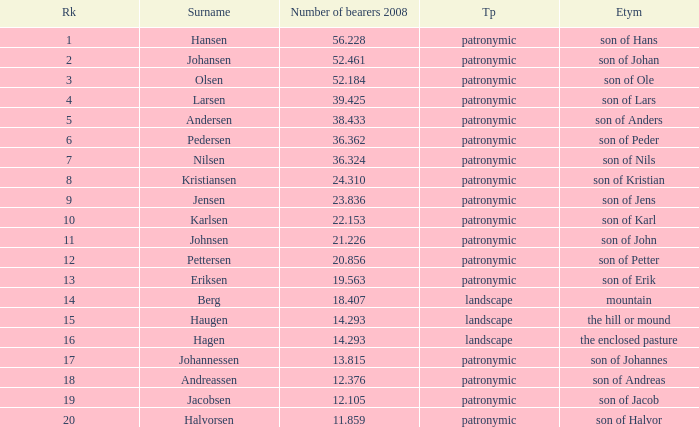What is Etymology, when Rank is 14? Mountain. 